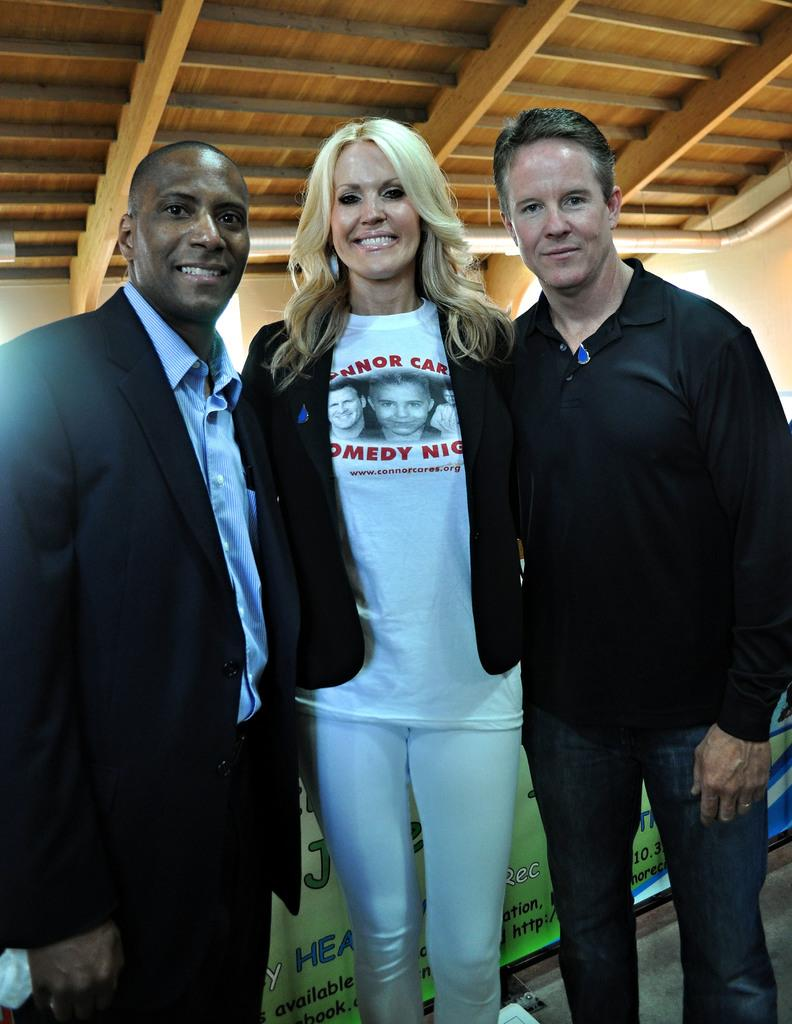How many people are in the image? There are three persons in the image. What are the persons doing in the image? The persons are posing for a camera. What expressions do the persons have in the image? The persons are smiling in the image. What can be seen in the background of the image? There is a banner and a wall in the background of the image. What type of substance is being poured into the mouth of the person in the image? There is no person having a substance poured into their mouth in the image. What channel is being broadcasted on the banner in the image? There is no channel mentioned on the banner in the image. 